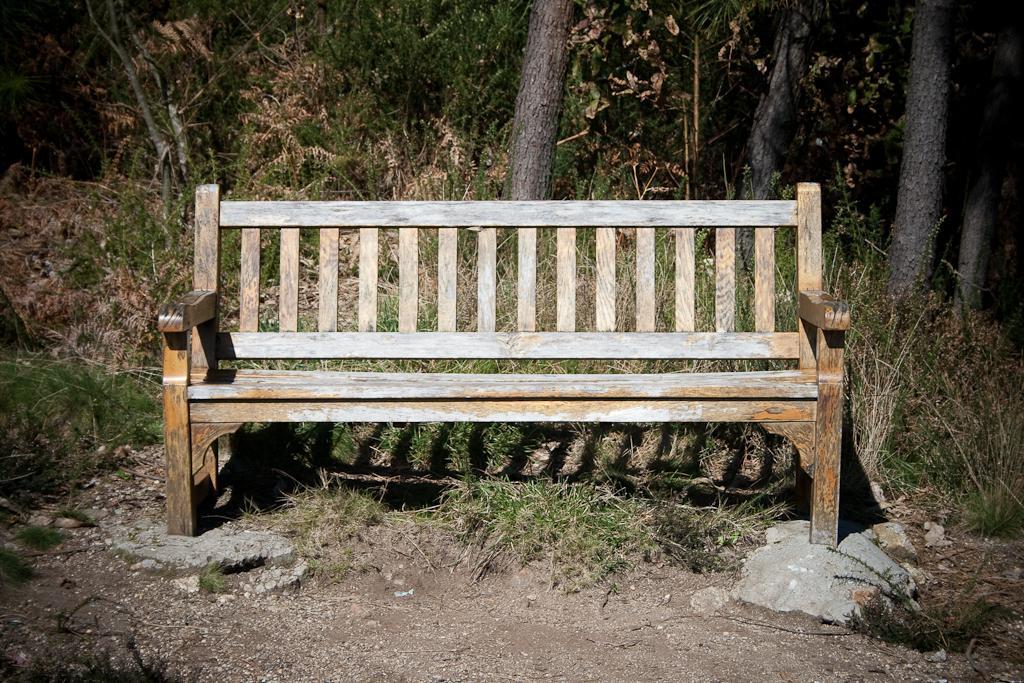Please provide a concise description of this image. In the foreground of the picture we can see grass, bench and soil. In the background there are trees and we can see dry leaves. 